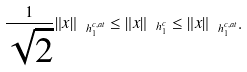<formula> <loc_0><loc_0><loc_500><loc_500>\frac { 1 } { \sqrt { 2 } } \| x \| _ { \ h _ { 1 } ^ { c , a t } } \leq \| x \| _ { \ h _ { 1 } ^ { c } } \leq \| x \| _ { \ h _ { 1 } ^ { c , a t } } .</formula> 